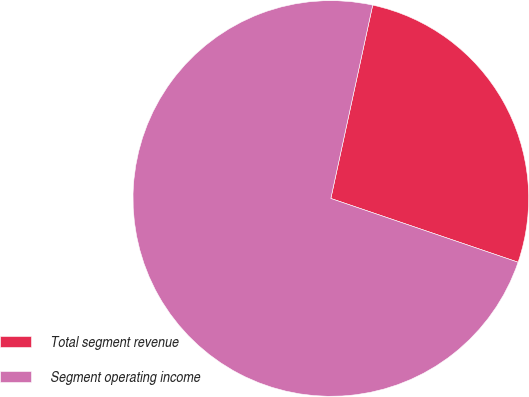<chart> <loc_0><loc_0><loc_500><loc_500><pie_chart><fcel>Total segment revenue<fcel>Segment operating income<nl><fcel>26.83%<fcel>73.17%<nl></chart> 